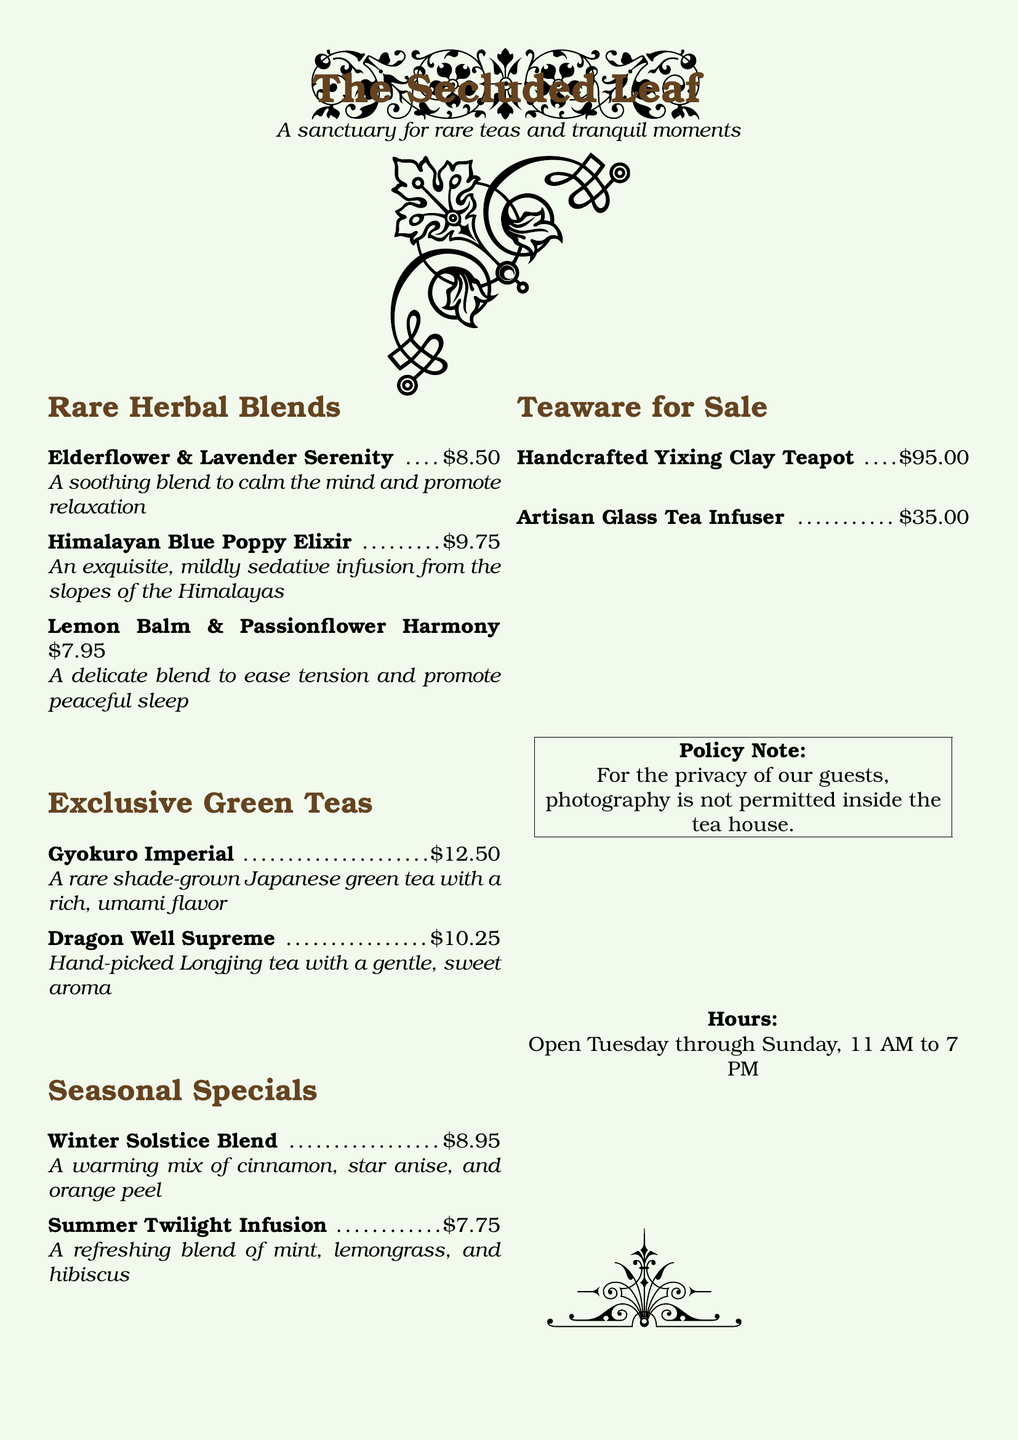what is the price of Elderflower & Lavender Serenity? The price of Elderflower & Lavender Serenity is stated in the document.
Answer: $8.50 how many exclusive green teas are listed? The document lists the exclusive green teas under a specific section, counting those teas gives the answer.
Answer: 2 what type of teapot is for sale? The type of teapot is specified in the "Teaware for Sale" section of the document.
Answer: Handcrafted Yixing Clay Teapot what is the opening day of the tea house? The opening days are outlined in the document, which details when the tea house operates.
Answer: Tuesday what is the price of the Artisan Glass Tea Infuser? The price for the Artisan Glass Tea Infuser is mentioned under the teaware section.
Answer: $35.00 what is the flavor profile of Gyokuro Imperial? The flavor profile of Gyokuro Imperial is described in the text under the exclusive green teas section.
Answer: rich, umami flavor what seasonal special contains cinnamon? The seasonal special blends are listed, and the one containing cinnamon can be identified.
Answer: Winter Solstice Blend how long is the tea house open each day? The hours of operation mention the opening times of the tea house.
Answer: 8 hours 